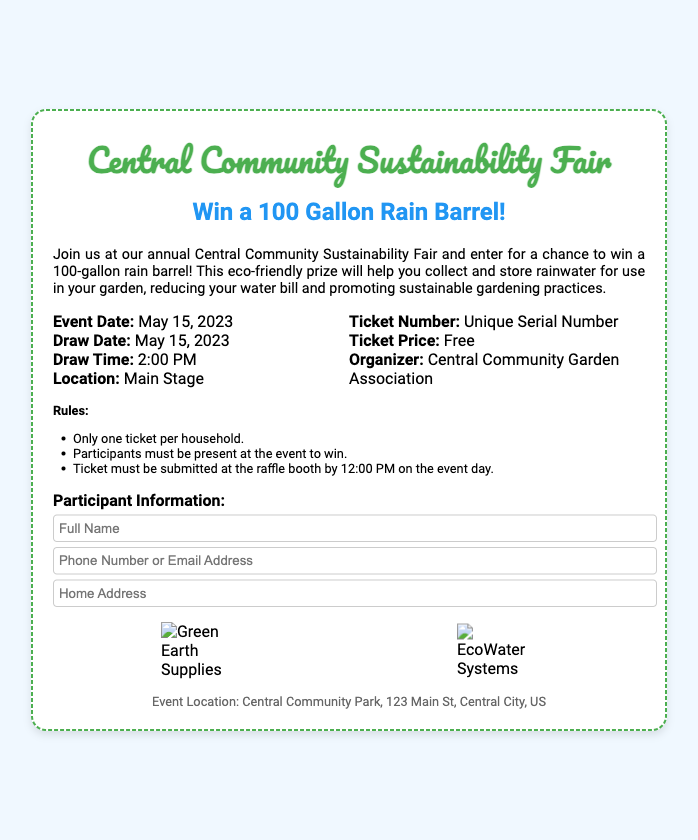What is the prize? The prize is the item that participants can win in the raffle, which is a 100-gallon rain barrel.
Answer: 100 Gallon Rain Barrel! What is the draw date? The draw date is the same day as the event, where the raffle winner will be chosen.
Answer: May 15, 2023 Who is the organizer? The organizer is the entity responsible for putting on the event and raffle, which can be found in the details section.
Answer: Central Community Garden Association What is the ticket price? The ticket price indicates how much participants have to pay to enter the raffle.
Answer: Free What time does the draw take place? The draw time specifies when the prize winner will be announced during the event.
Answer: 2:00 PM What must participants do to win? This requirement determines the conditions under which participants can claim their prize.
Answer: Must be present at the event to win What is the location of the event? This refers to where the event is taking place, which is necessary for participants to know before attending.
Answer: Main Stage What must be done by 12:00 PM on the event day? This indicates the deadline for submitting the ticket in order to be considered for the draw.
Answer: Ticket must be submitted at the raffle booth How many tickets can a household have? This question clarifies the limit imposed on ticket acquisition per household.
Answer: One ticket per household 